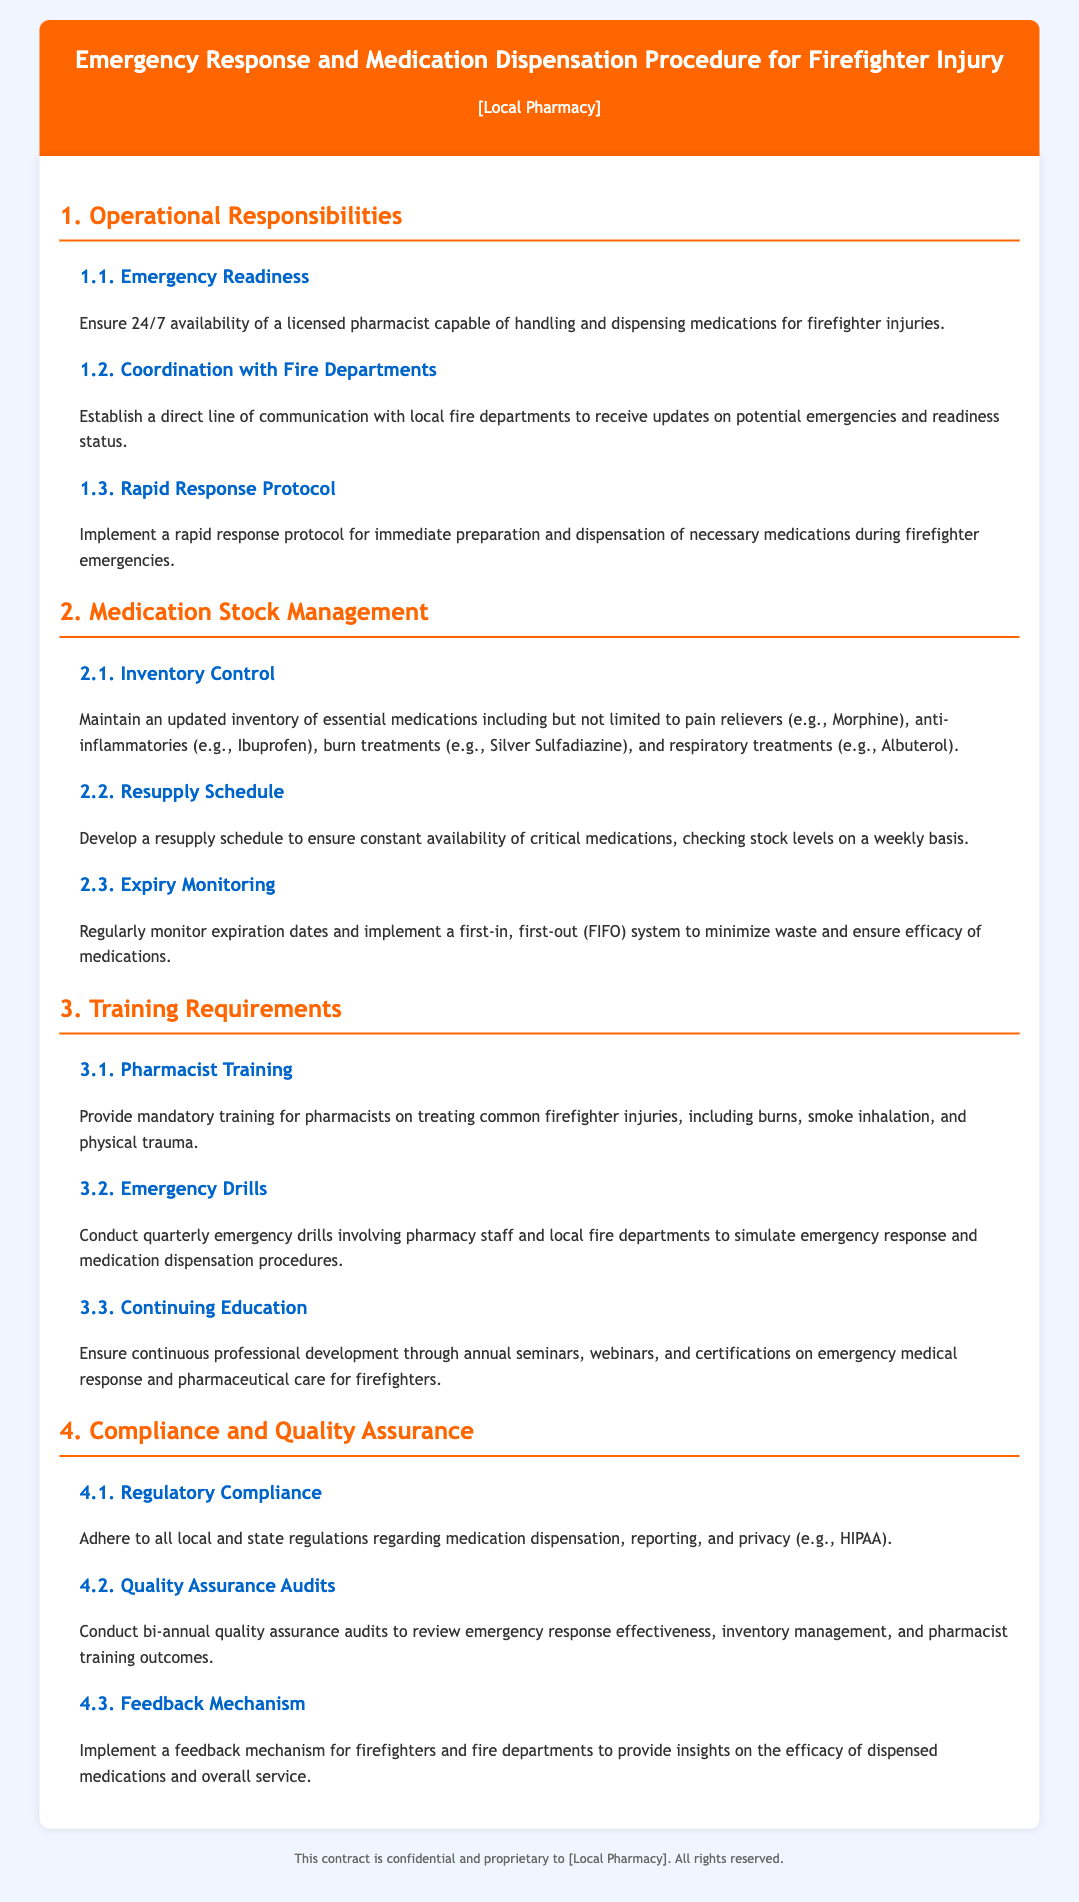What are the operational responsibilities outlined in the document? The section titled "1. Operational Responsibilities" lists the main responsibilities such as emergency readiness, coordination with fire departments, and rapid response protocol.
Answer: Emergency readiness, coordination with fire departments, rapid response protocol How many sections are there in the document? The document contains five main sections, each addressing different topics related to the contract.
Answer: Five What is the resupply schedule based on? The resupply schedule is developed to ensure constant availability of critical medications and involves checking stock levels on a weekly basis.
Answer: Weekly basis What type of training is required for pharmacists? The document specifies that pharmacists must undergo mandatory training on treating common firefighter injuries, including burns and smoke inhalation.
Answer: Mandatory training How often should emergency drills be conducted? The document states that emergency drills should be conducted quarterly involving pharmacy staff and local fire departments.
Answer: Quarterly What system is used to monitor medication expirations? A first-in, first-out (FIFO) system is implemented to minimize waste and ensure the efficacy of medications.
Answer: FIFO system What type of audits are mentioned for quality assurance? The document mentions conducting bi-annual quality assurance audits to review various aspects of the emergency response process.
Answer: Bi-annual quality assurance audits What specific medications are essential to maintain an inventory of? Essential medications include pain relievers, anti-inflammatories, burn treatments, and respiratory treatments.
Answer: Pain relievers, anti-inflammatories, burn treatments, respiratory treatments 